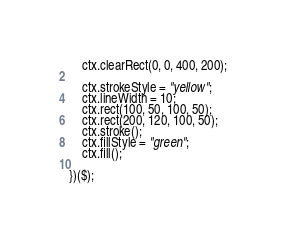<code> <loc_0><loc_0><loc_500><loc_500><_JavaScript_>
    ctx.clearRect(0, 0, 400, 200);

    ctx.strokeStyle = "yellow";
    ctx.lineWidth = 10;
    ctx.rect(100, 50, 100, 50);
    ctx.rect(200, 120, 100, 50);
    ctx.stroke();
    ctx.fillStyle = "green";
    ctx.fill();

})($);</code> 